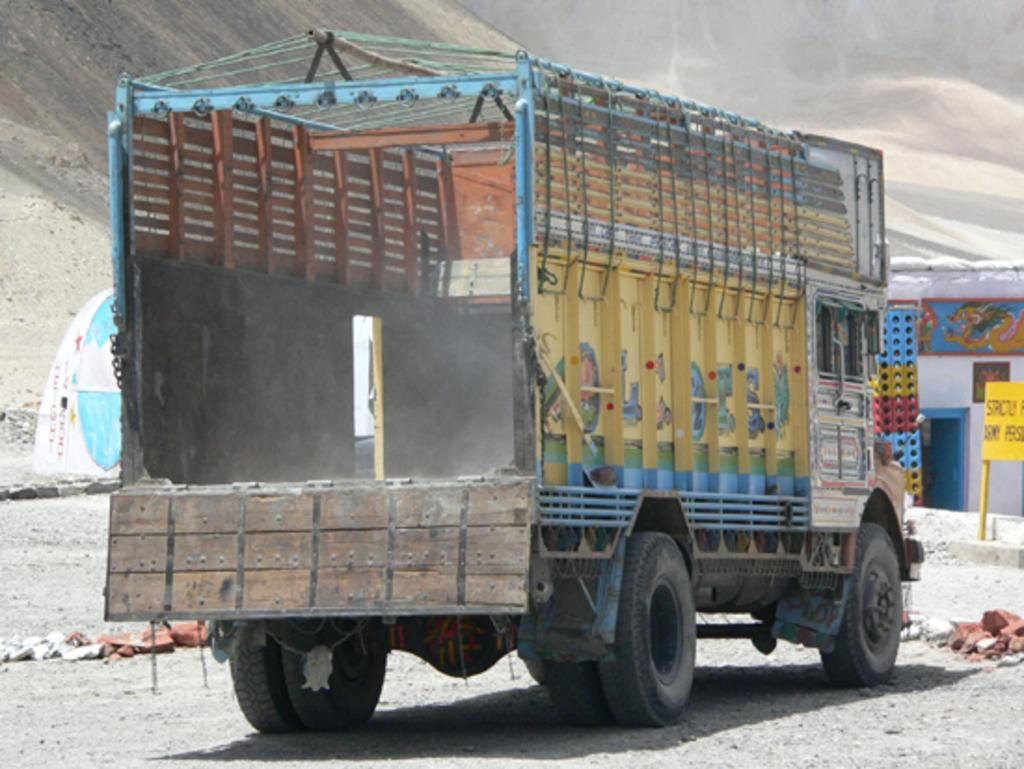What is the main subject in the center of the image? There is a vehicle in the center of the image. What can be seen in the background of the image? There are mountains, a house, a board, baskets, and a tent in the background of the image. What is the terrain like at the bottom of the image? There is sand and rocks at the bottom of the image. Can you see a giraffe walking on the sidewalk in the image? There is no giraffe or sidewalk present in the image. What type of pet can be seen in the image? There is no pet visible in the image. 